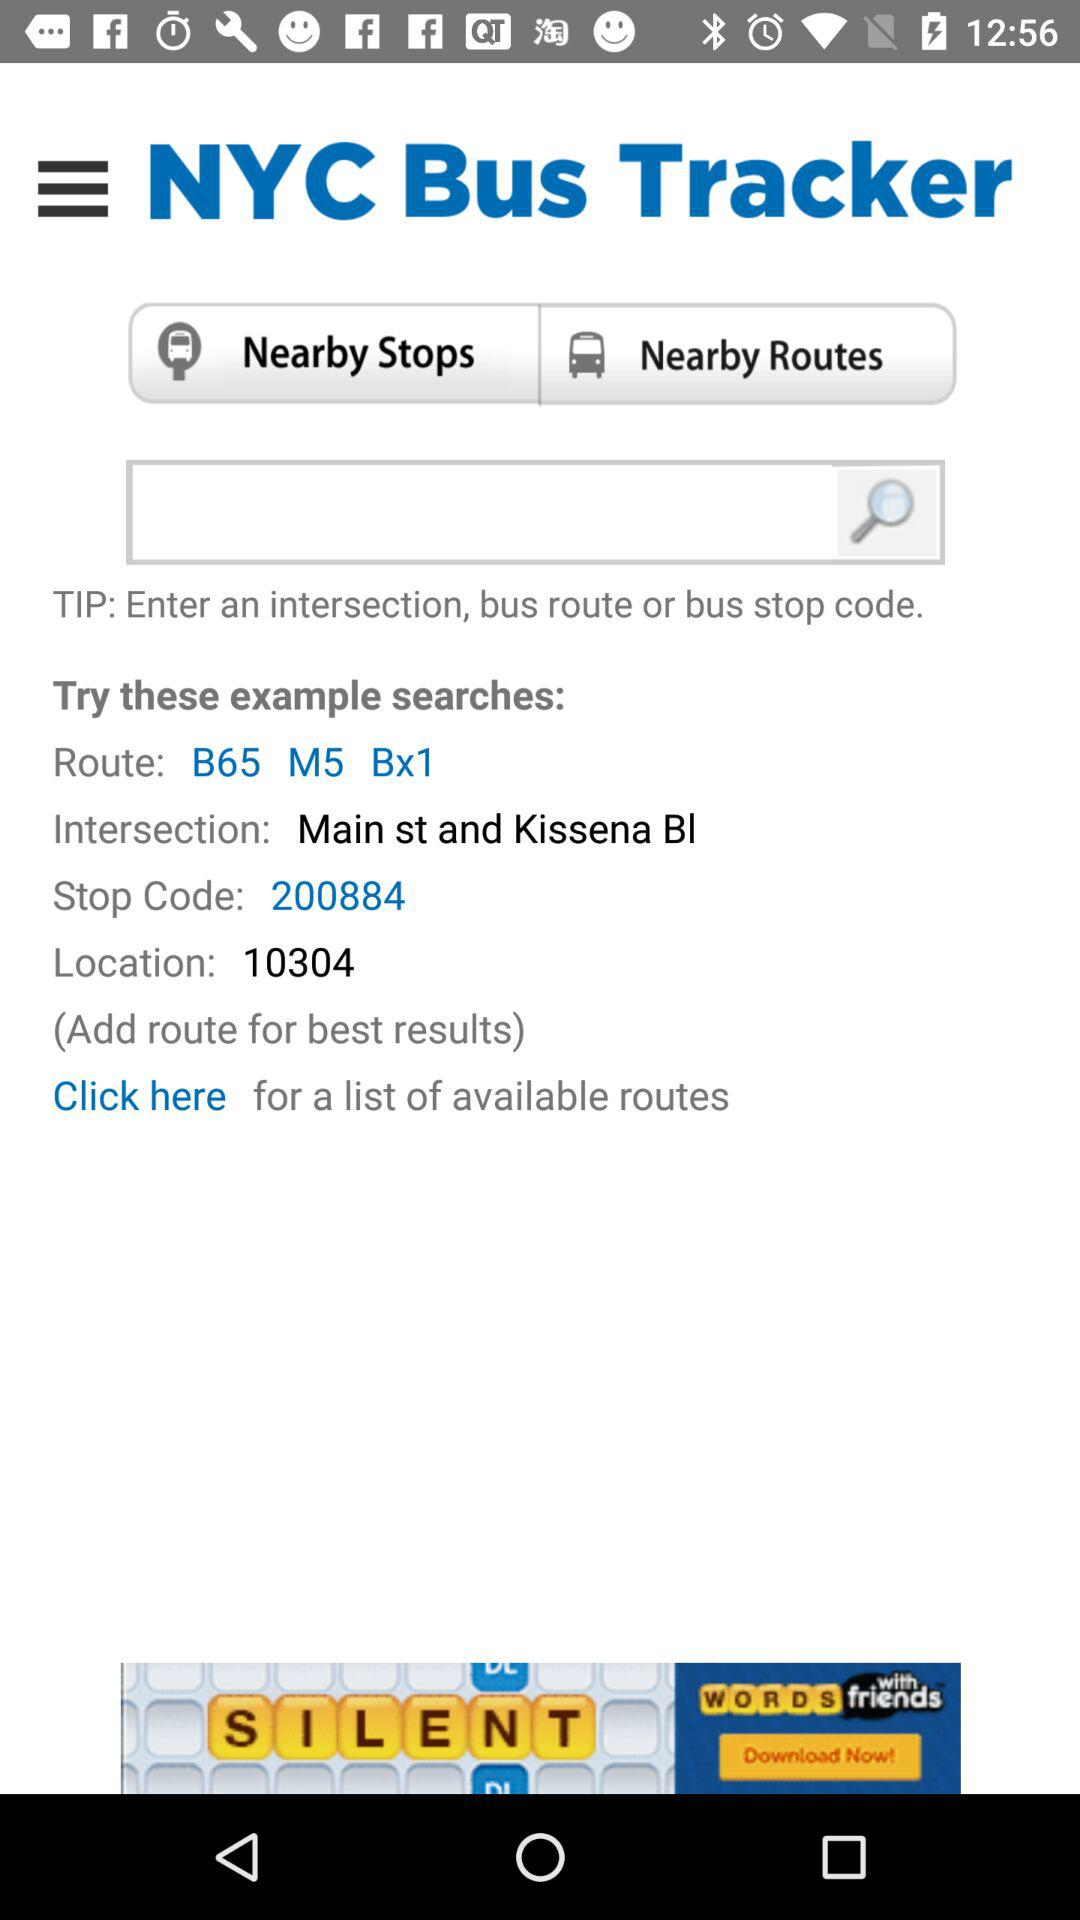What is the bus route? The bus route is B65 M5 Bx1. 